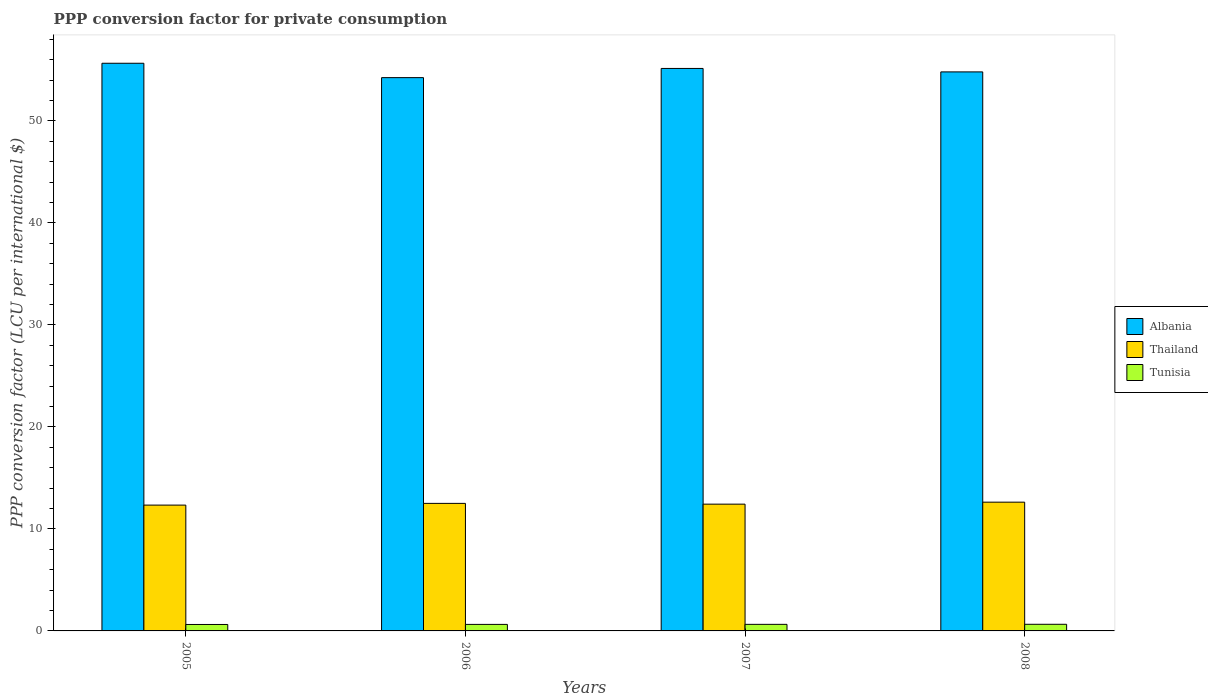How many different coloured bars are there?
Ensure brevity in your answer.  3. How many groups of bars are there?
Give a very brief answer. 4. Are the number of bars per tick equal to the number of legend labels?
Give a very brief answer. Yes. How many bars are there on the 2nd tick from the left?
Make the answer very short. 3. How many bars are there on the 3rd tick from the right?
Provide a short and direct response. 3. In how many cases, is the number of bars for a given year not equal to the number of legend labels?
Keep it short and to the point. 0. What is the PPP conversion factor for private consumption in Albania in 2006?
Make the answer very short. 54.24. Across all years, what is the maximum PPP conversion factor for private consumption in Albania?
Offer a very short reply. 55.65. Across all years, what is the minimum PPP conversion factor for private consumption in Tunisia?
Provide a short and direct response. 0.63. In which year was the PPP conversion factor for private consumption in Albania maximum?
Give a very brief answer. 2005. What is the total PPP conversion factor for private consumption in Thailand in the graph?
Offer a terse response. 49.89. What is the difference between the PPP conversion factor for private consumption in Thailand in 2005 and that in 2006?
Make the answer very short. -0.17. What is the difference between the PPP conversion factor for private consumption in Thailand in 2007 and the PPP conversion factor for private consumption in Albania in 2006?
Give a very brief answer. -41.82. What is the average PPP conversion factor for private consumption in Albania per year?
Offer a terse response. 54.96. In the year 2007, what is the difference between the PPP conversion factor for private consumption in Tunisia and PPP conversion factor for private consumption in Albania?
Your answer should be compact. -54.5. In how many years, is the PPP conversion factor for private consumption in Thailand greater than 28 LCU?
Your answer should be very brief. 0. What is the ratio of the PPP conversion factor for private consumption in Albania in 2007 to that in 2008?
Provide a succinct answer. 1.01. Is the difference between the PPP conversion factor for private consumption in Tunisia in 2006 and 2007 greater than the difference between the PPP conversion factor for private consumption in Albania in 2006 and 2007?
Give a very brief answer. Yes. What is the difference between the highest and the second highest PPP conversion factor for private consumption in Albania?
Your answer should be compact. 0.51. What is the difference between the highest and the lowest PPP conversion factor for private consumption in Tunisia?
Provide a short and direct response. 0.02. In how many years, is the PPP conversion factor for private consumption in Tunisia greater than the average PPP conversion factor for private consumption in Tunisia taken over all years?
Give a very brief answer. 2. What does the 1st bar from the left in 2008 represents?
Offer a very short reply. Albania. What does the 1st bar from the right in 2008 represents?
Ensure brevity in your answer.  Tunisia. Is it the case that in every year, the sum of the PPP conversion factor for private consumption in Thailand and PPP conversion factor for private consumption in Tunisia is greater than the PPP conversion factor for private consumption in Albania?
Your answer should be compact. No. How many bars are there?
Keep it short and to the point. 12. Are all the bars in the graph horizontal?
Offer a terse response. No. What is the difference between two consecutive major ticks on the Y-axis?
Your answer should be very brief. 10. Does the graph contain any zero values?
Give a very brief answer. No. Does the graph contain grids?
Offer a terse response. No. Where does the legend appear in the graph?
Offer a very short reply. Center right. How many legend labels are there?
Offer a very short reply. 3. How are the legend labels stacked?
Provide a succinct answer. Vertical. What is the title of the graph?
Your answer should be very brief. PPP conversion factor for private consumption. What is the label or title of the X-axis?
Ensure brevity in your answer.  Years. What is the label or title of the Y-axis?
Your answer should be very brief. PPP conversion factor (LCU per international $). What is the PPP conversion factor (LCU per international $) of Albania in 2005?
Give a very brief answer. 55.65. What is the PPP conversion factor (LCU per international $) of Thailand in 2005?
Offer a terse response. 12.33. What is the PPP conversion factor (LCU per international $) in Tunisia in 2005?
Your answer should be very brief. 0.63. What is the PPP conversion factor (LCU per international $) of Albania in 2006?
Provide a short and direct response. 54.24. What is the PPP conversion factor (LCU per international $) of Thailand in 2006?
Your response must be concise. 12.5. What is the PPP conversion factor (LCU per international $) of Tunisia in 2006?
Offer a very short reply. 0.64. What is the PPP conversion factor (LCU per international $) of Albania in 2007?
Make the answer very short. 55.15. What is the PPP conversion factor (LCU per international $) of Thailand in 2007?
Provide a succinct answer. 12.43. What is the PPP conversion factor (LCU per international $) in Tunisia in 2007?
Keep it short and to the point. 0.64. What is the PPP conversion factor (LCU per international $) in Albania in 2008?
Offer a very short reply. 54.81. What is the PPP conversion factor (LCU per international $) in Thailand in 2008?
Keep it short and to the point. 12.62. What is the PPP conversion factor (LCU per international $) of Tunisia in 2008?
Give a very brief answer. 0.65. Across all years, what is the maximum PPP conversion factor (LCU per international $) in Albania?
Offer a terse response. 55.65. Across all years, what is the maximum PPP conversion factor (LCU per international $) in Thailand?
Offer a very short reply. 12.62. Across all years, what is the maximum PPP conversion factor (LCU per international $) of Tunisia?
Your answer should be compact. 0.65. Across all years, what is the minimum PPP conversion factor (LCU per international $) of Albania?
Keep it short and to the point. 54.24. Across all years, what is the minimum PPP conversion factor (LCU per international $) of Thailand?
Offer a terse response. 12.33. Across all years, what is the minimum PPP conversion factor (LCU per international $) of Tunisia?
Offer a terse response. 0.63. What is the total PPP conversion factor (LCU per international $) in Albania in the graph?
Provide a short and direct response. 219.85. What is the total PPP conversion factor (LCU per international $) of Thailand in the graph?
Ensure brevity in your answer.  49.89. What is the total PPP conversion factor (LCU per international $) in Tunisia in the graph?
Your answer should be compact. 2.57. What is the difference between the PPP conversion factor (LCU per international $) of Albania in 2005 and that in 2006?
Make the answer very short. 1.41. What is the difference between the PPP conversion factor (LCU per international $) in Thailand in 2005 and that in 2006?
Provide a short and direct response. -0.17. What is the difference between the PPP conversion factor (LCU per international $) in Tunisia in 2005 and that in 2006?
Ensure brevity in your answer.  -0.01. What is the difference between the PPP conversion factor (LCU per international $) of Albania in 2005 and that in 2007?
Your response must be concise. 0.51. What is the difference between the PPP conversion factor (LCU per international $) of Thailand in 2005 and that in 2007?
Ensure brevity in your answer.  -0.09. What is the difference between the PPP conversion factor (LCU per international $) in Tunisia in 2005 and that in 2007?
Make the answer very short. -0.01. What is the difference between the PPP conversion factor (LCU per international $) of Albania in 2005 and that in 2008?
Your answer should be very brief. 0.85. What is the difference between the PPP conversion factor (LCU per international $) of Thailand in 2005 and that in 2008?
Offer a terse response. -0.29. What is the difference between the PPP conversion factor (LCU per international $) in Tunisia in 2005 and that in 2008?
Your answer should be very brief. -0.02. What is the difference between the PPP conversion factor (LCU per international $) in Albania in 2006 and that in 2007?
Your answer should be compact. -0.9. What is the difference between the PPP conversion factor (LCU per international $) in Thailand in 2006 and that in 2007?
Your answer should be compact. 0.07. What is the difference between the PPP conversion factor (LCU per international $) of Tunisia in 2006 and that in 2007?
Your answer should be compact. -0. What is the difference between the PPP conversion factor (LCU per international $) in Albania in 2006 and that in 2008?
Ensure brevity in your answer.  -0.56. What is the difference between the PPP conversion factor (LCU per international $) in Thailand in 2006 and that in 2008?
Offer a terse response. -0.12. What is the difference between the PPP conversion factor (LCU per international $) of Tunisia in 2006 and that in 2008?
Your response must be concise. -0.01. What is the difference between the PPP conversion factor (LCU per international $) in Albania in 2007 and that in 2008?
Your answer should be very brief. 0.34. What is the difference between the PPP conversion factor (LCU per international $) in Thailand in 2007 and that in 2008?
Your answer should be very brief. -0.2. What is the difference between the PPP conversion factor (LCU per international $) of Tunisia in 2007 and that in 2008?
Offer a terse response. -0.01. What is the difference between the PPP conversion factor (LCU per international $) of Albania in 2005 and the PPP conversion factor (LCU per international $) of Thailand in 2006?
Ensure brevity in your answer.  43.15. What is the difference between the PPP conversion factor (LCU per international $) of Albania in 2005 and the PPP conversion factor (LCU per international $) of Tunisia in 2006?
Keep it short and to the point. 55.01. What is the difference between the PPP conversion factor (LCU per international $) in Thailand in 2005 and the PPP conversion factor (LCU per international $) in Tunisia in 2006?
Provide a succinct answer. 11.69. What is the difference between the PPP conversion factor (LCU per international $) in Albania in 2005 and the PPP conversion factor (LCU per international $) in Thailand in 2007?
Offer a very short reply. 43.22. What is the difference between the PPP conversion factor (LCU per international $) in Albania in 2005 and the PPP conversion factor (LCU per international $) in Tunisia in 2007?
Offer a very short reply. 55.01. What is the difference between the PPP conversion factor (LCU per international $) of Thailand in 2005 and the PPP conversion factor (LCU per international $) of Tunisia in 2007?
Keep it short and to the point. 11.69. What is the difference between the PPP conversion factor (LCU per international $) of Albania in 2005 and the PPP conversion factor (LCU per international $) of Thailand in 2008?
Provide a short and direct response. 43.03. What is the difference between the PPP conversion factor (LCU per international $) in Albania in 2005 and the PPP conversion factor (LCU per international $) in Tunisia in 2008?
Offer a terse response. 55. What is the difference between the PPP conversion factor (LCU per international $) in Thailand in 2005 and the PPP conversion factor (LCU per international $) in Tunisia in 2008?
Your answer should be very brief. 11.68. What is the difference between the PPP conversion factor (LCU per international $) of Albania in 2006 and the PPP conversion factor (LCU per international $) of Thailand in 2007?
Your response must be concise. 41.82. What is the difference between the PPP conversion factor (LCU per international $) of Albania in 2006 and the PPP conversion factor (LCU per international $) of Tunisia in 2007?
Keep it short and to the point. 53.6. What is the difference between the PPP conversion factor (LCU per international $) in Thailand in 2006 and the PPP conversion factor (LCU per international $) in Tunisia in 2007?
Your response must be concise. 11.86. What is the difference between the PPP conversion factor (LCU per international $) in Albania in 2006 and the PPP conversion factor (LCU per international $) in Thailand in 2008?
Offer a very short reply. 41.62. What is the difference between the PPP conversion factor (LCU per international $) in Albania in 2006 and the PPP conversion factor (LCU per international $) in Tunisia in 2008?
Give a very brief answer. 53.59. What is the difference between the PPP conversion factor (LCU per international $) in Thailand in 2006 and the PPP conversion factor (LCU per international $) in Tunisia in 2008?
Offer a very short reply. 11.85. What is the difference between the PPP conversion factor (LCU per international $) of Albania in 2007 and the PPP conversion factor (LCU per international $) of Thailand in 2008?
Provide a short and direct response. 42.52. What is the difference between the PPP conversion factor (LCU per international $) in Albania in 2007 and the PPP conversion factor (LCU per international $) in Tunisia in 2008?
Ensure brevity in your answer.  54.5. What is the difference between the PPP conversion factor (LCU per international $) in Thailand in 2007 and the PPP conversion factor (LCU per international $) in Tunisia in 2008?
Provide a short and direct response. 11.78. What is the average PPP conversion factor (LCU per international $) in Albania per year?
Provide a succinct answer. 54.96. What is the average PPP conversion factor (LCU per international $) in Thailand per year?
Your response must be concise. 12.47. What is the average PPP conversion factor (LCU per international $) in Tunisia per year?
Offer a very short reply. 0.64. In the year 2005, what is the difference between the PPP conversion factor (LCU per international $) in Albania and PPP conversion factor (LCU per international $) in Thailand?
Give a very brief answer. 43.32. In the year 2005, what is the difference between the PPP conversion factor (LCU per international $) in Albania and PPP conversion factor (LCU per international $) in Tunisia?
Provide a short and direct response. 55.02. In the year 2005, what is the difference between the PPP conversion factor (LCU per international $) in Thailand and PPP conversion factor (LCU per international $) in Tunisia?
Give a very brief answer. 11.7. In the year 2006, what is the difference between the PPP conversion factor (LCU per international $) in Albania and PPP conversion factor (LCU per international $) in Thailand?
Your answer should be compact. 41.74. In the year 2006, what is the difference between the PPP conversion factor (LCU per international $) in Albania and PPP conversion factor (LCU per international $) in Tunisia?
Give a very brief answer. 53.6. In the year 2006, what is the difference between the PPP conversion factor (LCU per international $) of Thailand and PPP conversion factor (LCU per international $) of Tunisia?
Your response must be concise. 11.86. In the year 2007, what is the difference between the PPP conversion factor (LCU per international $) of Albania and PPP conversion factor (LCU per international $) of Thailand?
Give a very brief answer. 42.72. In the year 2007, what is the difference between the PPP conversion factor (LCU per international $) of Albania and PPP conversion factor (LCU per international $) of Tunisia?
Give a very brief answer. 54.5. In the year 2007, what is the difference between the PPP conversion factor (LCU per international $) of Thailand and PPP conversion factor (LCU per international $) of Tunisia?
Provide a short and direct response. 11.79. In the year 2008, what is the difference between the PPP conversion factor (LCU per international $) of Albania and PPP conversion factor (LCU per international $) of Thailand?
Keep it short and to the point. 42.18. In the year 2008, what is the difference between the PPP conversion factor (LCU per international $) in Albania and PPP conversion factor (LCU per international $) in Tunisia?
Make the answer very short. 54.16. In the year 2008, what is the difference between the PPP conversion factor (LCU per international $) of Thailand and PPP conversion factor (LCU per international $) of Tunisia?
Give a very brief answer. 11.97. What is the ratio of the PPP conversion factor (LCU per international $) of Albania in 2005 to that in 2006?
Provide a succinct answer. 1.03. What is the ratio of the PPP conversion factor (LCU per international $) of Thailand in 2005 to that in 2006?
Your answer should be very brief. 0.99. What is the ratio of the PPP conversion factor (LCU per international $) of Tunisia in 2005 to that in 2006?
Your response must be concise. 0.99. What is the ratio of the PPP conversion factor (LCU per international $) in Albania in 2005 to that in 2007?
Ensure brevity in your answer.  1.01. What is the ratio of the PPP conversion factor (LCU per international $) in Thailand in 2005 to that in 2007?
Your response must be concise. 0.99. What is the ratio of the PPP conversion factor (LCU per international $) of Tunisia in 2005 to that in 2007?
Make the answer very short. 0.98. What is the ratio of the PPP conversion factor (LCU per international $) of Albania in 2005 to that in 2008?
Your answer should be very brief. 1.02. What is the ratio of the PPP conversion factor (LCU per international $) of Thailand in 2005 to that in 2008?
Offer a very short reply. 0.98. What is the ratio of the PPP conversion factor (LCU per international $) in Tunisia in 2005 to that in 2008?
Give a very brief answer. 0.97. What is the ratio of the PPP conversion factor (LCU per international $) in Albania in 2006 to that in 2007?
Provide a short and direct response. 0.98. What is the ratio of the PPP conversion factor (LCU per international $) of Thailand in 2006 to that in 2007?
Ensure brevity in your answer.  1.01. What is the ratio of the PPP conversion factor (LCU per international $) in Tunisia in 2006 to that in 2008?
Ensure brevity in your answer.  0.98. What is the ratio of the PPP conversion factor (LCU per international $) in Thailand in 2007 to that in 2008?
Make the answer very short. 0.98. What is the ratio of the PPP conversion factor (LCU per international $) of Tunisia in 2007 to that in 2008?
Your answer should be very brief. 0.99. What is the difference between the highest and the second highest PPP conversion factor (LCU per international $) in Albania?
Your answer should be very brief. 0.51. What is the difference between the highest and the second highest PPP conversion factor (LCU per international $) of Thailand?
Give a very brief answer. 0.12. What is the difference between the highest and the second highest PPP conversion factor (LCU per international $) in Tunisia?
Provide a succinct answer. 0.01. What is the difference between the highest and the lowest PPP conversion factor (LCU per international $) of Albania?
Provide a short and direct response. 1.41. What is the difference between the highest and the lowest PPP conversion factor (LCU per international $) in Thailand?
Keep it short and to the point. 0.29. What is the difference between the highest and the lowest PPP conversion factor (LCU per international $) in Tunisia?
Offer a terse response. 0.02. 